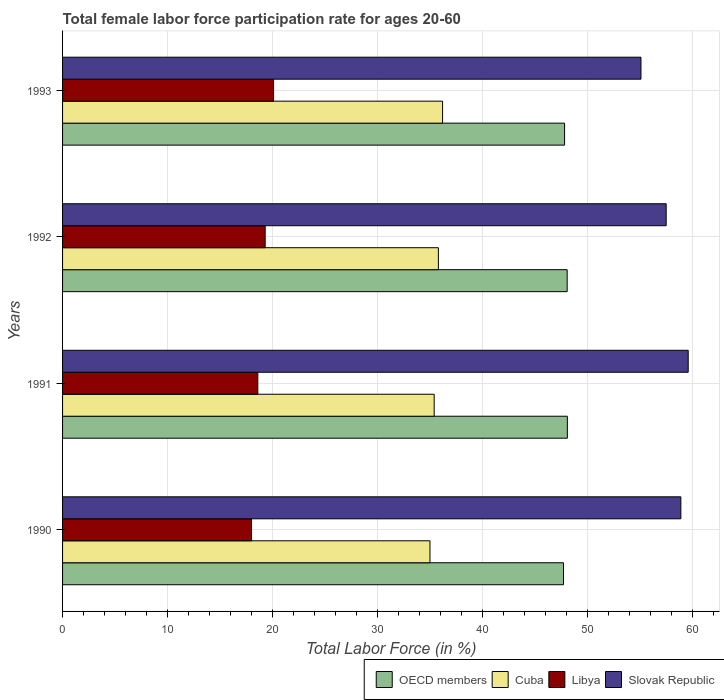How many groups of bars are there?
Make the answer very short. 4. Are the number of bars on each tick of the Y-axis equal?
Your answer should be very brief. Yes. How many bars are there on the 1st tick from the top?
Provide a succinct answer. 4. How many bars are there on the 2nd tick from the bottom?
Give a very brief answer. 4. What is the label of the 4th group of bars from the top?
Your answer should be compact. 1990. What is the female labor force participation rate in Cuba in 1990?
Make the answer very short. 35. Across all years, what is the maximum female labor force participation rate in OECD members?
Your answer should be very brief. 48.09. Across all years, what is the minimum female labor force participation rate in OECD members?
Your answer should be compact. 47.72. What is the total female labor force participation rate in OECD members in the graph?
Your answer should be very brief. 191.7. What is the difference between the female labor force participation rate in Slovak Republic in 1991 and that in 1992?
Your response must be concise. 2.1. What is the difference between the female labor force participation rate in Libya in 1990 and the female labor force participation rate in Cuba in 1992?
Make the answer very short. -17.8. What is the average female labor force participation rate in OECD members per year?
Offer a very short reply. 47.93. In how many years, is the female labor force participation rate in Cuba greater than 22 %?
Make the answer very short. 4. What is the ratio of the female labor force participation rate in Libya in 1990 to that in 1992?
Your answer should be compact. 0.93. Is the difference between the female labor force participation rate in Libya in 1991 and 1993 greater than the difference between the female labor force participation rate in Cuba in 1991 and 1993?
Offer a terse response. No. What is the difference between the highest and the second highest female labor force participation rate in Cuba?
Make the answer very short. 0.4. What is the difference between the highest and the lowest female labor force participation rate in OECD members?
Offer a terse response. 0.37. Is it the case that in every year, the sum of the female labor force participation rate in Slovak Republic and female labor force participation rate in Cuba is greater than the sum of female labor force participation rate in Libya and female labor force participation rate in OECD members?
Make the answer very short. Yes. What does the 1st bar from the top in 1990 represents?
Your response must be concise. Slovak Republic. What does the 3rd bar from the bottom in 1992 represents?
Offer a very short reply. Libya. Are all the bars in the graph horizontal?
Offer a very short reply. Yes. How many years are there in the graph?
Offer a terse response. 4. What is the difference between two consecutive major ticks on the X-axis?
Provide a short and direct response. 10. Are the values on the major ticks of X-axis written in scientific E-notation?
Provide a succinct answer. No. Does the graph contain grids?
Keep it short and to the point. Yes. Where does the legend appear in the graph?
Give a very brief answer. Bottom right. How are the legend labels stacked?
Provide a succinct answer. Horizontal. What is the title of the graph?
Your answer should be very brief. Total female labor force participation rate for ages 20-60. Does "Bhutan" appear as one of the legend labels in the graph?
Offer a very short reply. No. What is the label or title of the Y-axis?
Offer a terse response. Years. What is the Total Labor Force (in %) in OECD members in 1990?
Your answer should be very brief. 47.72. What is the Total Labor Force (in %) of Libya in 1990?
Keep it short and to the point. 18. What is the Total Labor Force (in %) of Slovak Republic in 1990?
Your response must be concise. 58.9. What is the Total Labor Force (in %) of OECD members in 1991?
Your answer should be very brief. 48.09. What is the Total Labor Force (in %) of Cuba in 1991?
Give a very brief answer. 35.4. What is the Total Labor Force (in %) of Libya in 1991?
Make the answer very short. 18.6. What is the Total Labor Force (in %) in Slovak Republic in 1991?
Ensure brevity in your answer.  59.6. What is the Total Labor Force (in %) in OECD members in 1992?
Ensure brevity in your answer.  48.07. What is the Total Labor Force (in %) in Cuba in 1992?
Make the answer very short. 35.8. What is the Total Labor Force (in %) in Libya in 1992?
Your answer should be very brief. 19.3. What is the Total Labor Force (in %) of Slovak Republic in 1992?
Your answer should be compact. 57.5. What is the Total Labor Force (in %) in OECD members in 1993?
Provide a short and direct response. 47.82. What is the Total Labor Force (in %) of Cuba in 1993?
Provide a short and direct response. 36.2. What is the Total Labor Force (in %) in Libya in 1993?
Your answer should be very brief. 20.1. What is the Total Labor Force (in %) of Slovak Republic in 1993?
Offer a very short reply. 55.1. Across all years, what is the maximum Total Labor Force (in %) of OECD members?
Keep it short and to the point. 48.09. Across all years, what is the maximum Total Labor Force (in %) of Cuba?
Your answer should be compact. 36.2. Across all years, what is the maximum Total Labor Force (in %) in Libya?
Offer a very short reply. 20.1. Across all years, what is the maximum Total Labor Force (in %) of Slovak Republic?
Provide a succinct answer. 59.6. Across all years, what is the minimum Total Labor Force (in %) of OECD members?
Provide a short and direct response. 47.72. Across all years, what is the minimum Total Labor Force (in %) in Libya?
Keep it short and to the point. 18. Across all years, what is the minimum Total Labor Force (in %) of Slovak Republic?
Make the answer very short. 55.1. What is the total Total Labor Force (in %) of OECD members in the graph?
Give a very brief answer. 191.7. What is the total Total Labor Force (in %) of Cuba in the graph?
Your response must be concise. 142.4. What is the total Total Labor Force (in %) in Libya in the graph?
Provide a succinct answer. 76. What is the total Total Labor Force (in %) of Slovak Republic in the graph?
Provide a succinct answer. 231.1. What is the difference between the Total Labor Force (in %) of OECD members in 1990 and that in 1991?
Your response must be concise. -0.37. What is the difference between the Total Labor Force (in %) of Libya in 1990 and that in 1991?
Your answer should be very brief. -0.6. What is the difference between the Total Labor Force (in %) in OECD members in 1990 and that in 1992?
Offer a terse response. -0.35. What is the difference between the Total Labor Force (in %) of Cuba in 1990 and that in 1992?
Provide a succinct answer. -0.8. What is the difference between the Total Labor Force (in %) in Libya in 1990 and that in 1992?
Your answer should be compact. -1.3. What is the difference between the Total Labor Force (in %) of Slovak Republic in 1990 and that in 1992?
Offer a terse response. 1.4. What is the difference between the Total Labor Force (in %) of OECD members in 1990 and that in 1993?
Offer a very short reply. -0.1. What is the difference between the Total Labor Force (in %) in OECD members in 1991 and that in 1992?
Give a very brief answer. 0.02. What is the difference between the Total Labor Force (in %) of OECD members in 1991 and that in 1993?
Keep it short and to the point. 0.27. What is the difference between the Total Labor Force (in %) of Cuba in 1991 and that in 1993?
Offer a terse response. -0.8. What is the difference between the Total Labor Force (in %) of Libya in 1991 and that in 1993?
Your answer should be very brief. -1.5. What is the difference between the Total Labor Force (in %) in Slovak Republic in 1991 and that in 1993?
Provide a short and direct response. 4.5. What is the difference between the Total Labor Force (in %) of OECD members in 1992 and that in 1993?
Your answer should be very brief. 0.25. What is the difference between the Total Labor Force (in %) in Cuba in 1992 and that in 1993?
Ensure brevity in your answer.  -0.4. What is the difference between the Total Labor Force (in %) of Libya in 1992 and that in 1993?
Your answer should be compact. -0.8. What is the difference between the Total Labor Force (in %) of OECD members in 1990 and the Total Labor Force (in %) of Cuba in 1991?
Offer a terse response. 12.32. What is the difference between the Total Labor Force (in %) in OECD members in 1990 and the Total Labor Force (in %) in Libya in 1991?
Your response must be concise. 29.12. What is the difference between the Total Labor Force (in %) of OECD members in 1990 and the Total Labor Force (in %) of Slovak Republic in 1991?
Offer a very short reply. -11.88. What is the difference between the Total Labor Force (in %) of Cuba in 1990 and the Total Labor Force (in %) of Libya in 1991?
Your response must be concise. 16.4. What is the difference between the Total Labor Force (in %) in Cuba in 1990 and the Total Labor Force (in %) in Slovak Republic in 1991?
Offer a very short reply. -24.6. What is the difference between the Total Labor Force (in %) of Libya in 1990 and the Total Labor Force (in %) of Slovak Republic in 1991?
Your response must be concise. -41.6. What is the difference between the Total Labor Force (in %) in OECD members in 1990 and the Total Labor Force (in %) in Cuba in 1992?
Provide a short and direct response. 11.92. What is the difference between the Total Labor Force (in %) in OECD members in 1990 and the Total Labor Force (in %) in Libya in 1992?
Give a very brief answer. 28.42. What is the difference between the Total Labor Force (in %) in OECD members in 1990 and the Total Labor Force (in %) in Slovak Republic in 1992?
Your answer should be very brief. -9.78. What is the difference between the Total Labor Force (in %) of Cuba in 1990 and the Total Labor Force (in %) of Libya in 1992?
Your answer should be compact. 15.7. What is the difference between the Total Labor Force (in %) of Cuba in 1990 and the Total Labor Force (in %) of Slovak Republic in 1992?
Give a very brief answer. -22.5. What is the difference between the Total Labor Force (in %) in Libya in 1990 and the Total Labor Force (in %) in Slovak Republic in 1992?
Make the answer very short. -39.5. What is the difference between the Total Labor Force (in %) in OECD members in 1990 and the Total Labor Force (in %) in Cuba in 1993?
Keep it short and to the point. 11.52. What is the difference between the Total Labor Force (in %) in OECD members in 1990 and the Total Labor Force (in %) in Libya in 1993?
Offer a very short reply. 27.62. What is the difference between the Total Labor Force (in %) of OECD members in 1990 and the Total Labor Force (in %) of Slovak Republic in 1993?
Provide a short and direct response. -7.38. What is the difference between the Total Labor Force (in %) of Cuba in 1990 and the Total Labor Force (in %) of Libya in 1993?
Your answer should be very brief. 14.9. What is the difference between the Total Labor Force (in %) of Cuba in 1990 and the Total Labor Force (in %) of Slovak Republic in 1993?
Make the answer very short. -20.1. What is the difference between the Total Labor Force (in %) in Libya in 1990 and the Total Labor Force (in %) in Slovak Republic in 1993?
Your answer should be compact. -37.1. What is the difference between the Total Labor Force (in %) of OECD members in 1991 and the Total Labor Force (in %) of Cuba in 1992?
Ensure brevity in your answer.  12.29. What is the difference between the Total Labor Force (in %) of OECD members in 1991 and the Total Labor Force (in %) of Libya in 1992?
Ensure brevity in your answer.  28.79. What is the difference between the Total Labor Force (in %) of OECD members in 1991 and the Total Labor Force (in %) of Slovak Republic in 1992?
Provide a succinct answer. -9.41. What is the difference between the Total Labor Force (in %) in Cuba in 1991 and the Total Labor Force (in %) in Slovak Republic in 1992?
Provide a short and direct response. -22.1. What is the difference between the Total Labor Force (in %) in Libya in 1991 and the Total Labor Force (in %) in Slovak Republic in 1992?
Keep it short and to the point. -38.9. What is the difference between the Total Labor Force (in %) of OECD members in 1991 and the Total Labor Force (in %) of Cuba in 1993?
Your response must be concise. 11.89. What is the difference between the Total Labor Force (in %) of OECD members in 1991 and the Total Labor Force (in %) of Libya in 1993?
Your response must be concise. 27.99. What is the difference between the Total Labor Force (in %) in OECD members in 1991 and the Total Labor Force (in %) in Slovak Republic in 1993?
Give a very brief answer. -7.01. What is the difference between the Total Labor Force (in %) of Cuba in 1991 and the Total Labor Force (in %) of Slovak Republic in 1993?
Provide a succinct answer. -19.7. What is the difference between the Total Labor Force (in %) in Libya in 1991 and the Total Labor Force (in %) in Slovak Republic in 1993?
Your answer should be compact. -36.5. What is the difference between the Total Labor Force (in %) in OECD members in 1992 and the Total Labor Force (in %) in Cuba in 1993?
Make the answer very short. 11.87. What is the difference between the Total Labor Force (in %) of OECD members in 1992 and the Total Labor Force (in %) of Libya in 1993?
Keep it short and to the point. 27.97. What is the difference between the Total Labor Force (in %) of OECD members in 1992 and the Total Labor Force (in %) of Slovak Republic in 1993?
Offer a very short reply. -7.03. What is the difference between the Total Labor Force (in %) in Cuba in 1992 and the Total Labor Force (in %) in Slovak Republic in 1993?
Provide a short and direct response. -19.3. What is the difference between the Total Labor Force (in %) in Libya in 1992 and the Total Labor Force (in %) in Slovak Republic in 1993?
Provide a short and direct response. -35.8. What is the average Total Labor Force (in %) of OECD members per year?
Your response must be concise. 47.92. What is the average Total Labor Force (in %) of Cuba per year?
Give a very brief answer. 35.6. What is the average Total Labor Force (in %) in Libya per year?
Keep it short and to the point. 19. What is the average Total Labor Force (in %) of Slovak Republic per year?
Provide a succinct answer. 57.77. In the year 1990, what is the difference between the Total Labor Force (in %) of OECD members and Total Labor Force (in %) of Cuba?
Give a very brief answer. 12.72. In the year 1990, what is the difference between the Total Labor Force (in %) of OECD members and Total Labor Force (in %) of Libya?
Your response must be concise. 29.72. In the year 1990, what is the difference between the Total Labor Force (in %) of OECD members and Total Labor Force (in %) of Slovak Republic?
Give a very brief answer. -11.18. In the year 1990, what is the difference between the Total Labor Force (in %) in Cuba and Total Labor Force (in %) in Libya?
Give a very brief answer. 17. In the year 1990, what is the difference between the Total Labor Force (in %) of Cuba and Total Labor Force (in %) of Slovak Republic?
Your answer should be very brief. -23.9. In the year 1990, what is the difference between the Total Labor Force (in %) of Libya and Total Labor Force (in %) of Slovak Republic?
Your answer should be very brief. -40.9. In the year 1991, what is the difference between the Total Labor Force (in %) of OECD members and Total Labor Force (in %) of Cuba?
Provide a succinct answer. 12.69. In the year 1991, what is the difference between the Total Labor Force (in %) in OECD members and Total Labor Force (in %) in Libya?
Give a very brief answer. 29.49. In the year 1991, what is the difference between the Total Labor Force (in %) of OECD members and Total Labor Force (in %) of Slovak Republic?
Provide a succinct answer. -11.51. In the year 1991, what is the difference between the Total Labor Force (in %) of Cuba and Total Labor Force (in %) of Slovak Republic?
Your answer should be very brief. -24.2. In the year 1991, what is the difference between the Total Labor Force (in %) of Libya and Total Labor Force (in %) of Slovak Republic?
Give a very brief answer. -41. In the year 1992, what is the difference between the Total Labor Force (in %) of OECD members and Total Labor Force (in %) of Cuba?
Make the answer very short. 12.27. In the year 1992, what is the difference between the Total Labor Force (in %) in OECD members and Total Labor Force (in %) in Libya?
Give a very brief answer. 28.77. In the year 1992, what is the difference between the Total Labor Force (in %) of OECD members and Total Labor Force (in %) of Slovak Republic?
Your answer should be very brief. -9.43. In the year 1992, what is the difference between the Total Labor Force (in %) in Cuba and Total Labor Force (in %) in Slovak Republic?
Make the answer very short. -21.7. In the year 1992, what is the difference between the Total Labor Force (in %) of Libya and Total Labor Force (in %) of Slovak Republic?
Give a very brief answer. -38.2. In the year 1993, what is the difference between the Total Labor Force (in %) in OECD members and Total Labor Force (in %) in Cuba?
Keep it short and to the point. 11.62. In the year 1993, what is the difference between the Total Labor Force (in %) of OECD members and Total Labor Force (in %) of Libya?
Offer a terse response. 27.72. In the year 1993, what is the difference between the Total Labor Force (in %) of OECD members and Total Labor Force (in %) of Slovak Republic?
Ensure brevity in your answer.  -7.28. In the year 1993, what is the difference between the Total Labor Force (in %) in Cuba and Total Labor Force (in %) in Libya?
Provide a short and direct response. 16.1. In the year 1993, what is the difference between the Total Labor Force (in %) in Cuba and Total Labor Force (in %) in Slovak Republic?
Ensure brevity in your answer.  -18.9. In the year 1993, what is the difference between the Total Labor Force (in %) in Libya and Total Labor Force (in %) in Slovak Republic?
Keep it short and to the point. -35. What is the ratio of the Total Labor Force (in %) of OECD members in 1990 to that in 1991?
Keep it short and to the point. 0.99. What is the ratio of the Total Labor Force (in %) of Cuba in 1990 to that in 1991?
Your answer should be compact. 0.99. What is the ratio of the Total Labor Force (in %) in Slovak Republic in 1990 to that in 1991?
Your answer should be compact. 0.99. What is the ratio of the Total Labor Force (in %) of Cuba in 1990 to that in 1992?
Provide a succinct answer. 0.98. What is the ratio of the Total Labor Force (in %) of Libya in 1990 to that in 1992?
Provide a short and direct response. 0.93. What is the ratio of the Total Labor Force (in %) in Slovak Republic in 1990 to that in 1992?
Your answer should be very brief. 1.02. What is the ratio of the Total Labor Force (in %) in Cuba in 1990 to that in 1993?
Keep it short and to the point. 0.97. What is the ratio of the Total Labor Force (in %) in Libya in 1990 to that in 1993?
Ensure brevity in your answer.  0.9. What is the ratio of the Total Labor Force (in %) of Slovak Republic in 1990 to that in 1993?
Ensure brevity in your answer.  1.07. What is the ratio of the Total Labor Force (in %) in OECD members in 1991 to that in 1992?
Ensure brevity in your answer.  1. What is the ratio of the Total Labor Force (in %) of Cuba in 1991 to that in 1992?
Keep it short and to the point. 0.99. What is the ratio of the Total Labor Force (in %) of Libya in 1991 to that in 1992?
Give a very brief answer. 0.96. What is the ratio of the Total Labor Force (in %) of Slovak Republic in 1991 to that in 1992?
Offer a very short reply. 1.04. What is the ratio of the Total Labor Force (in %) of OECD members in 1991 to that in 1993?
Offer a terse response. 1.01. What is the ratio of the Total Labor Force (in %) of Cuba in 1991 to that in 1993?
Make the answer very short. 0.98. What is the ratio of the Total Labor Force (in %) in Libya in 1991 to that in 1993?
Provide a succinct answer. 0.93. What is the ratio of the Total Labor Force (in %) of Slovak Republic in 1991 to that in 1993?
Your answer should be very brief. 1.08. What is the ratio of the Total Labor Force (in %) in OECD members in 1992 to that in 1993?
Provide a short and direct response. 1.01. What is the ratio of the Total Labor Force (in %) in Libya in 1992 to that in 1993?
Ensure brevity in your answer.  0.96. What is the ratio of the Total Labor Force (in %) in Slovak Republic in 1992 to that in 1993?
Provide a succinct answer. 1.04. What is the difference between the highest and the second highest Total Labor Force (in %) in OECD members?
Keep it short and to the point. 0.02. What is the difference between the highest and the second highest Total Labor Force (in %) in Libya?
Give a very brief answer. 0.8. What is the difference between the highest and the second highest Total Labor Force (in %) in Slovak Republic?
Your response must be concise. 0.7. What is the difference between the highest and the lowest Total Labor Force (in %) in OECD members?
Offer a terse response. 0.37. What is the difference between the highest and the lowest Total Labor Force (in %) of Cuba?
Provide a short and direct response. 1.2. What is the difference between the highest and the lowest Total Labor Force (in %) of Slovak Republic?
Ensure brevity in your answer.  4.5. 